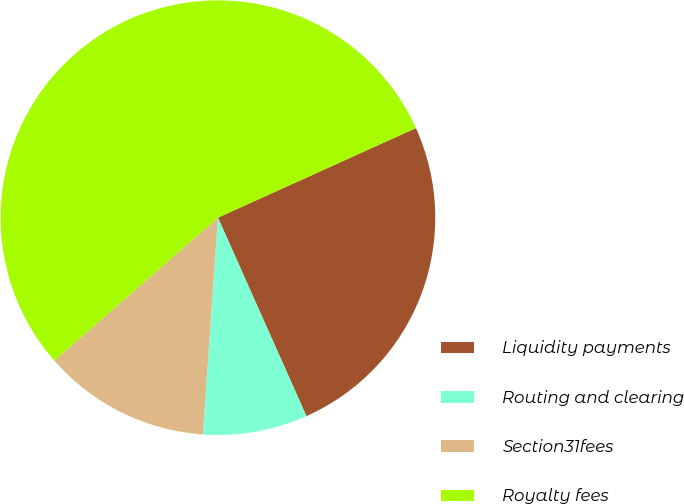<chart> <loc_0><loc_0><loc_500><loc_500><pie_chart><fcel>Liquidity payments<fcel>Routing and clearing<fcel>Section31fees<fcel>Royalty fees<nl><fcel>25.09%<fcel>7.78%<fcel>12.47%<fcel>54.66%<nl></chart> 